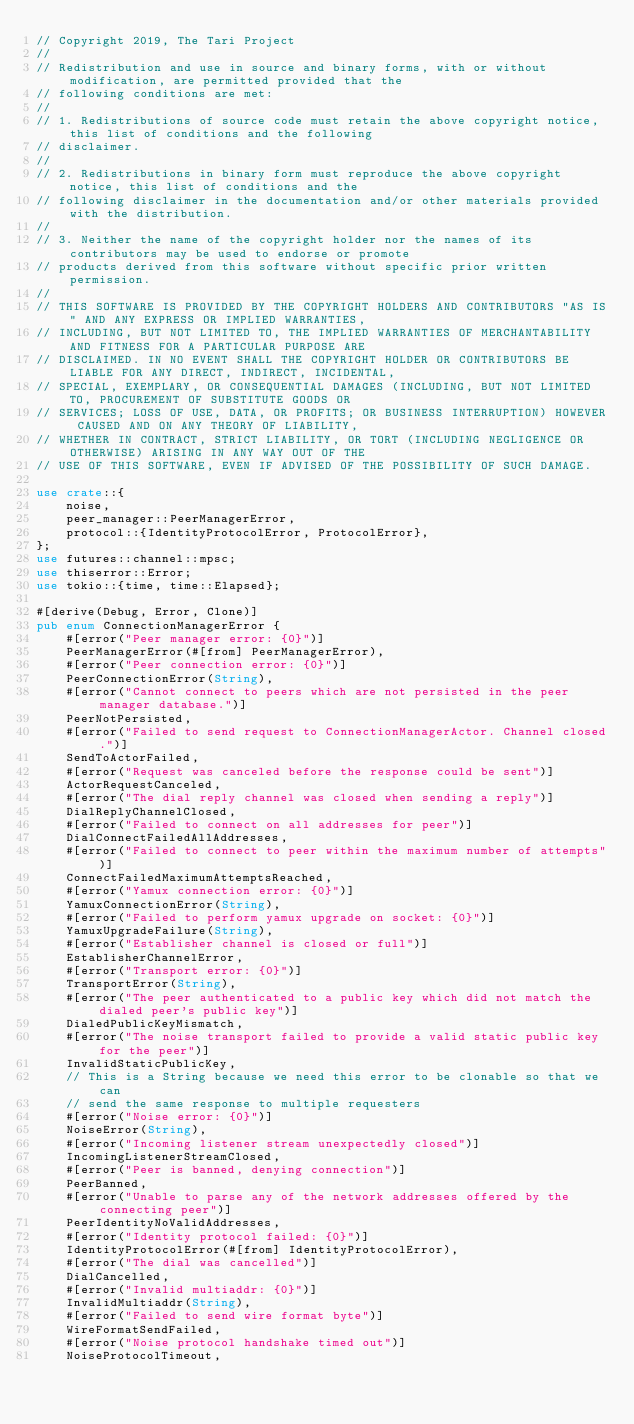<code> <loc_0><loc_0><loc_500><loc_500><_Rust_>// Copyright 2019, The Tari Project
//
// Redistribution and use in source and binary forms, with or without modification, are permitted provided that the
// following conditions are met:
//
// 1. Redistributions of source code must retain the above copyright notice, this list of conditions and the following
// disclaimer.
//
// 2. Redistributions in binary form must reproduce the above copyright notice, this list of conditions and the
// following disclaimer in the documentation and/or other materials provided with the distribution.
//
// 3. Neither the name of the copyright holder nor the names of its contributors may be used to endorse or promote
// products derived from this software without specific prior written permission.
//
// THIS SOFTWARE IS PROVIDED BY THE COPYRIGHT HOLDERS AND CONTRIBUTORS "AS IS" AND ANY EXPRESS OR IMPLIED WARRANTIES,
// INCLUDING, BUT NOT LIMITED TO, THE IMPLIED WARRANTIES OF MERCHANTABILITY AND FITNESS FOR A PARTICULAR PURPOSE ARE
// DISCLAIMED. IN NO EVENT SHALL THE COPYRIGHT HOLDER OR CONTRIBUTORS BE LIABLE FOR ANY DIRECT, INDIRECT, INCIDENTAL,
// SPECIAL, EXEMPLARY, OR CONSEQUENTIAL DAMAGES (INCLUDING, BUT NOT LIMITED TO, PROCUREMENT OF SUBSTITUTE GOODS OR
// SERVICES; LOSS OF USE, DATA, OR PROFITS; OR BUSINESS INTERRUPTION) HOWEVER CAUSED AND ON ANY THEORY OF LIABILITY,
// WHETHER IN CONTRACT, STRICT LIABILITY, OR TORT (INCLUDING NEGLIGENCE OR OTHERWISE) ARISING IN ANY WAY OUT OF THE
// USE OF THIS SOFTWARE, EVEN IF ADVISED OF THE POSSIBILITY OF SUCH DAMAGE.

use crate::{
    noise,
    peer_manager::PeerManagerError,
    protocol::{IdentityProtocolError, ProtocolError},
};
use futures::channel::mpsc;
use thiserror::Error;
use tokio::{time, time::Elapsed};

#[derive(Debug, Error, Clone)]
pub enum ConnectionManagerError {
    #[error("Peer manager error: {0}")]
    PeerManagerError(#[from] PeerManagerError),
    #[error("Peer connection error: {0}")]
    PeerConnectionError(String),
    #[error("Cannot connect to peers which are not persisted in the peer manager database.")]
    PeerNotPersisted,
    #[error("Failed to send request to ConnectionManagerActor. Channel closed.")]
    SendToActorFailed,
    #[error("Request was canceled before the response could be sent")]
    ActorRequestCanceled,
    #[error("The dial reply channel was closed when sending a reply")]
    DialReplyChannelClosed,
    #[error("Failed to connect on all addresses for peer")]
    DialConnectFailedAllAddresses,
    #[error("Failed to connect to peer within the maximum number of attempts")]
    ConnectFailedMaximumAttemptsReached,
    #[error("Yamux connection error: {0}")]
    YamuxConnectionError(String),
    #[error("Failed to perform yamux upgrade on socket: {0}")]
    YamuxUpgradeFailure(String),
    #[error("Establisher channel is closed or full")]
    EstablisherChannelError,
    #[error("Transport error: {0}")]
    TransportError(String),
    #[error("The peer authenticated to a public key which did not match the dialed peer's public key")]
    DialedPublicKeyMismatch,
    #[error("The noise transport failed to provide a valid static public key for the peer")]
    InvalidStaticPublicKey,
    // This is a String because we need this error to be clonable so that we can
    // send the same response to multiple requesters
    #[error("Noise error: {0}")]
    NoiseError(String),
    #[error("Incoming listener stream unexpectedly closed")]
    IncomingListenerStreamClosed,
    #[error("Peer is banned, denying connection")]
    PeerBanned,
    #[error("Unable to parse any of the network addresses offered by the connecting peer")]
    PeerIdentityNoValidAddresses,
    #[error("Identity protocol failed: {0}")]
    IdentityProtocolError(#[from] IdentityProtocolError),
    #[error("The dial was cancelled")]
    DialCancelled,
    #[error("Invalid multiaddr: {0}")]
    InvalidMultiaddr(String),
    #[error("Failed to send wire format byte")]
    WireFormatSendFailed,
    #[error("Noise protocol handshake timed out")]
    NoiseProtocolTimeout,</code> 